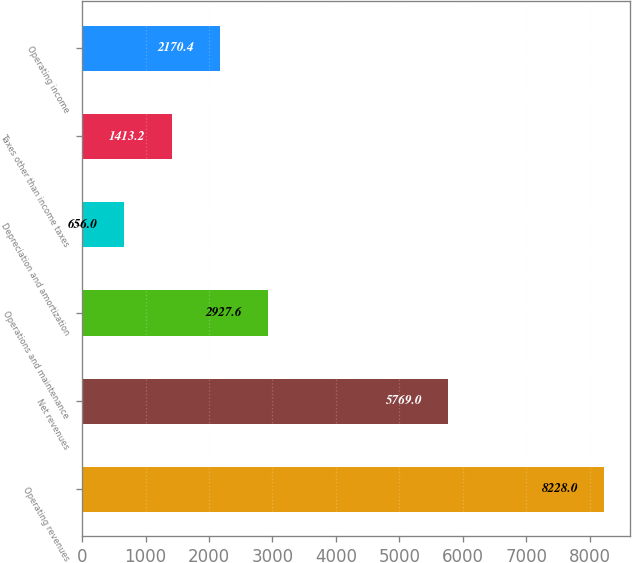Convert chart. <chart><loc_0><loc_0><loc_500><loc_500><bar_chart><fcel>Operating revenues<fcel>Net revenues<fcel>Operations and maintenance<fcel>Depreciation and amortization<fcel>Taxes other than income taxes<fcel>Operating income<nl><fcel>8228<fcel>5769<fcel>2927.6<fcel>656<fcel>1413.2<fcel>2170.4<nl></chart> 